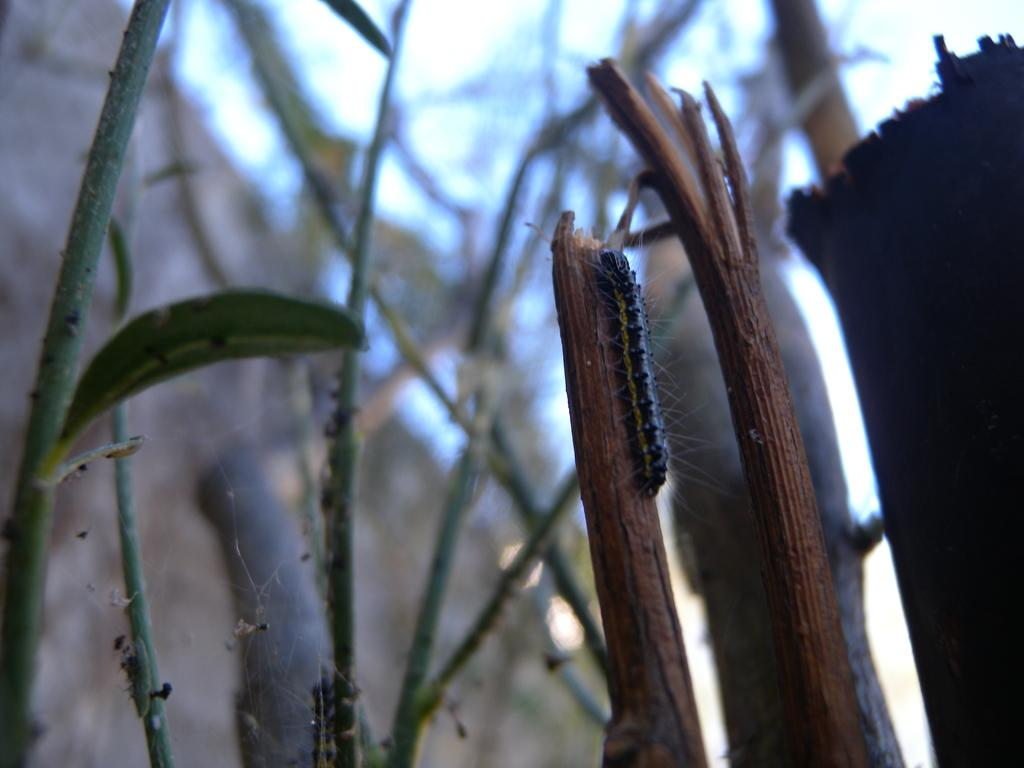What is the main subject of the image? There is a caterpillar on a branch of a tree in the image. Can you describe the branch the caterpillar is on? There is another branch of a tree nearby in the image. What can be seen in the background of the image? There are plants and a wood in the background of the image, as well as the sky. What type of horn can be seen on the scarecrow in the image? There is no scarecrow present in the image, and therefore no horn can be seen. 